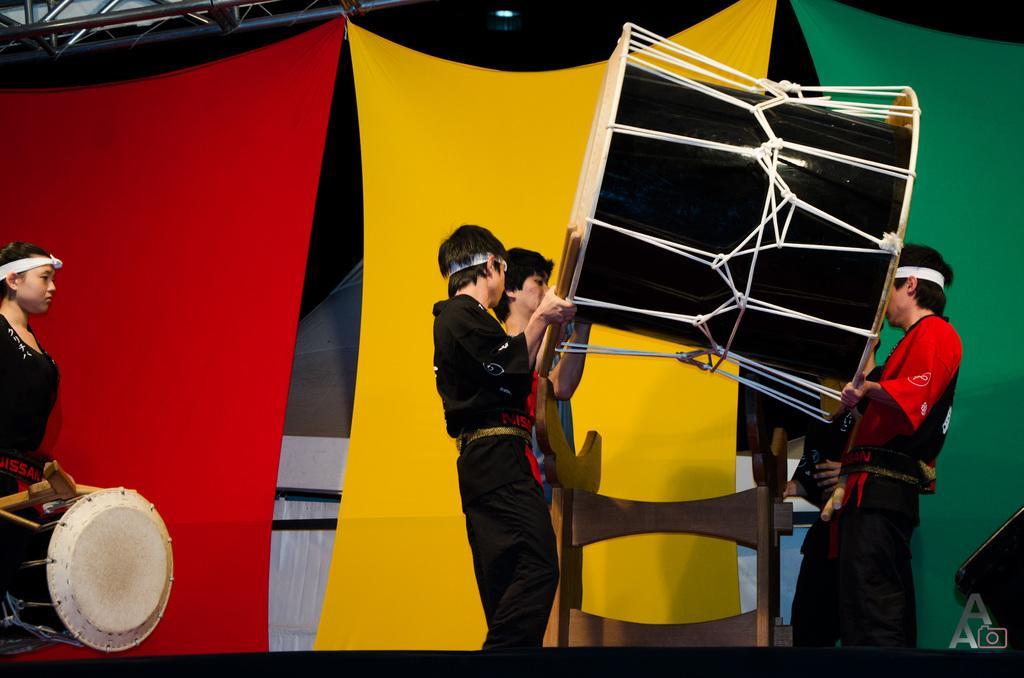Can you describe this image briefly? In this picture these persons are standing. These persons holding drum. This person wear drum. This person hold sticks. On the background we can see curtains. This is rod 